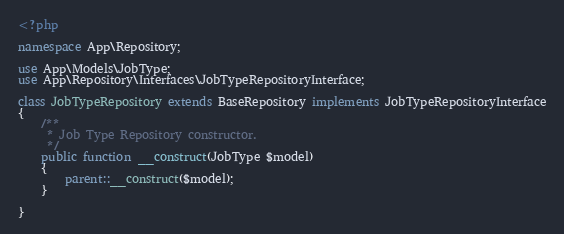<code> <loc_0><loc_0><loc_500><loc_500><_PHP_><?php

namespace App\Repository;

use App\Models\JobType;
use App\Repository\Interfaces\JobTypeRepositoryInterface;

class JobTypeRepository extends BaseRepository implements JobTypeRepositoryInterface
{
    /**
     * Job Type Repository constructor.
     */
    public function __construct(JobType $model)
    {
        parent::__construct($model);
    }

}
</code> 